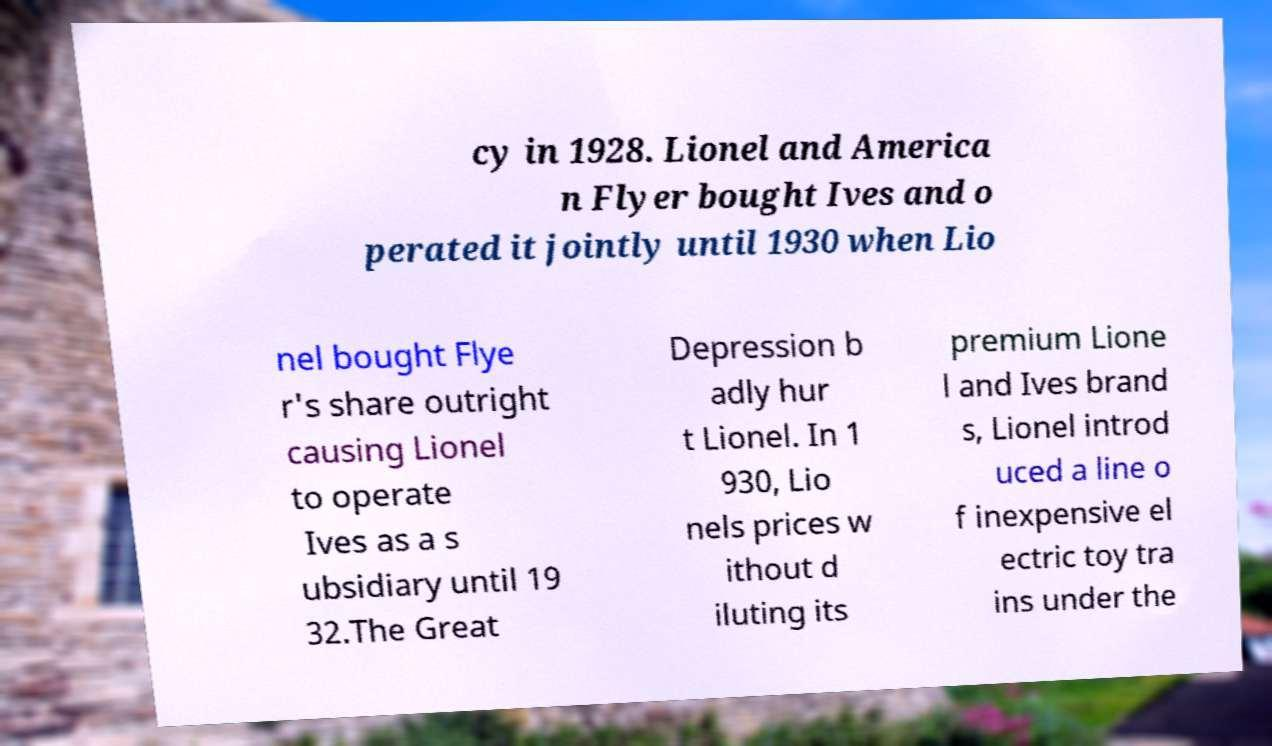Could you extract and type out the text from this image? cy in 1928. Lionel and America n Flyer bought Ives and o perated it jointly until 1930 when Lio nel bought Flye r's share outright causing Lionel to operate Ives as a s ubsidiary until 19 32.The Great Depression b adly hur t Lionel. In 1 930, Lio nels prices w ithout d iluting its premium Lione l and Ives brand s, Lionel introd uced a line o f inexpensive el ectric toy tra ins under the 